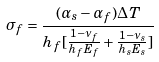Convert formula to latex. <formula><loc_0><loc_0><loc_500><loc_500>\sigma _ { f } = \frac { ( \alpha _ { s } - \alpha _ { f } ) \Delta T } { h _ { f } [ \frac { 1 - \nu _ { f } } { h _ { f } E _ { f } } + \frac { 1 - \nu _ { s } } { h _ { s } E _ { s } } ] }</formula> 